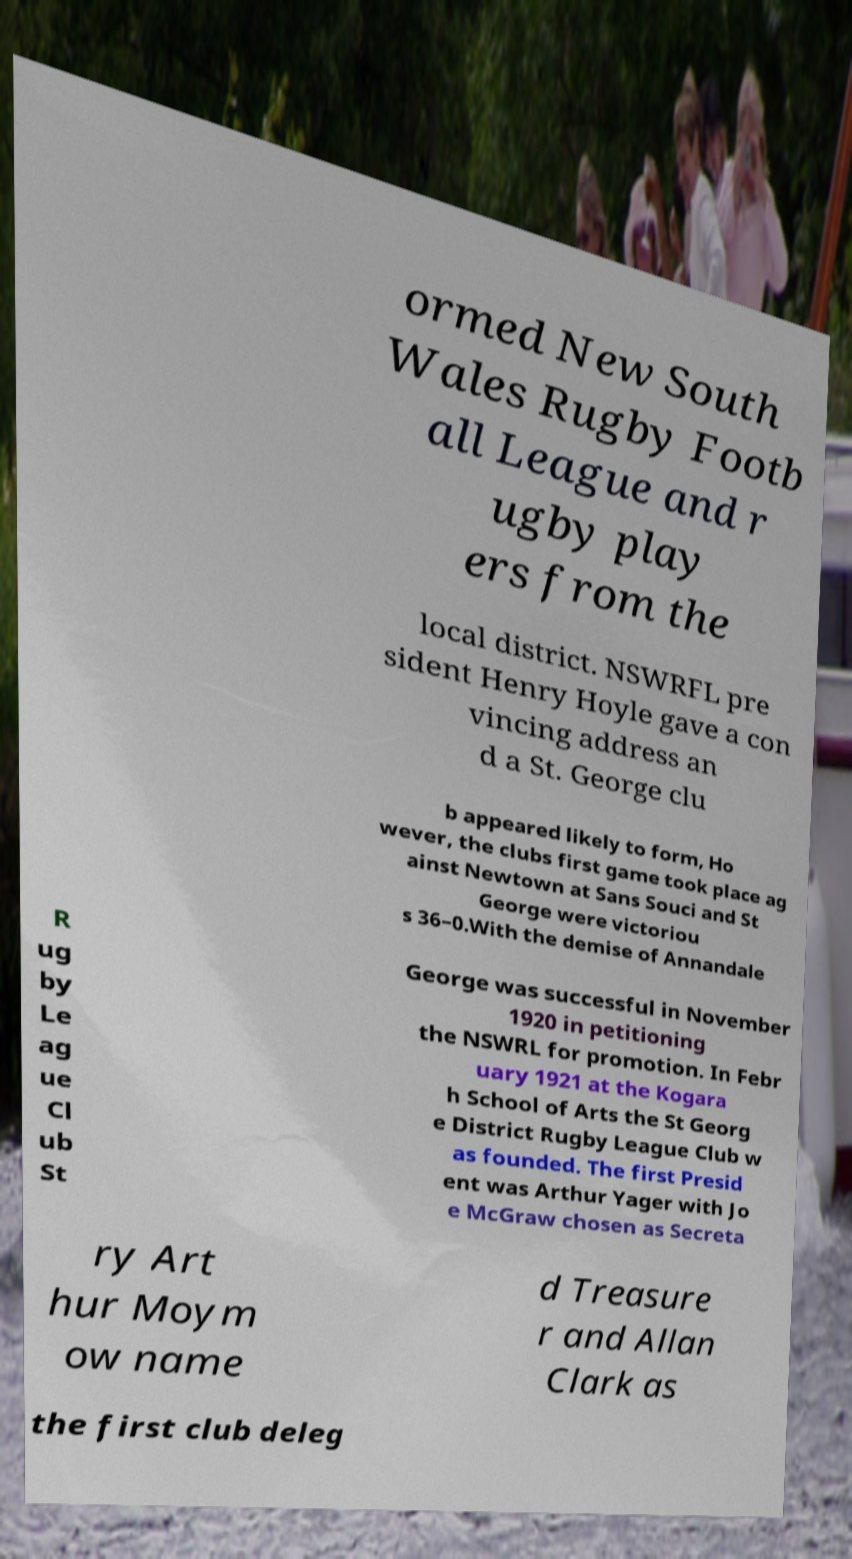Can you read and provide the text displayed in the image?This photo seems to have some interesting text. Can you extract and type it out for me? ormed New South Wales Rugby Footb all League and r ugby play ers from the local district. NSWRFL pre sident Henry Hoyle gave a con vincing address an d a St. George clu b appeared likely to form, Ho wever, the clubs first game took place ag ainst Newtown at Sans Souci and St George were victoriou s 36–0.With the demise of Annandale R ug by Le ag ue Cl ub St George was successful in November 1920 in petitioning the NSWRL for promotion. In Febr uary 1921 at the Kogara h School of Arts the St Georg e District Rugby League Club w as founded. The first Presid ent was Arthur Yager with Jo e McGraw chosen as Secreta ry Art hur Moym ow name d Treasure r and Allan Clark as the first club deleg 